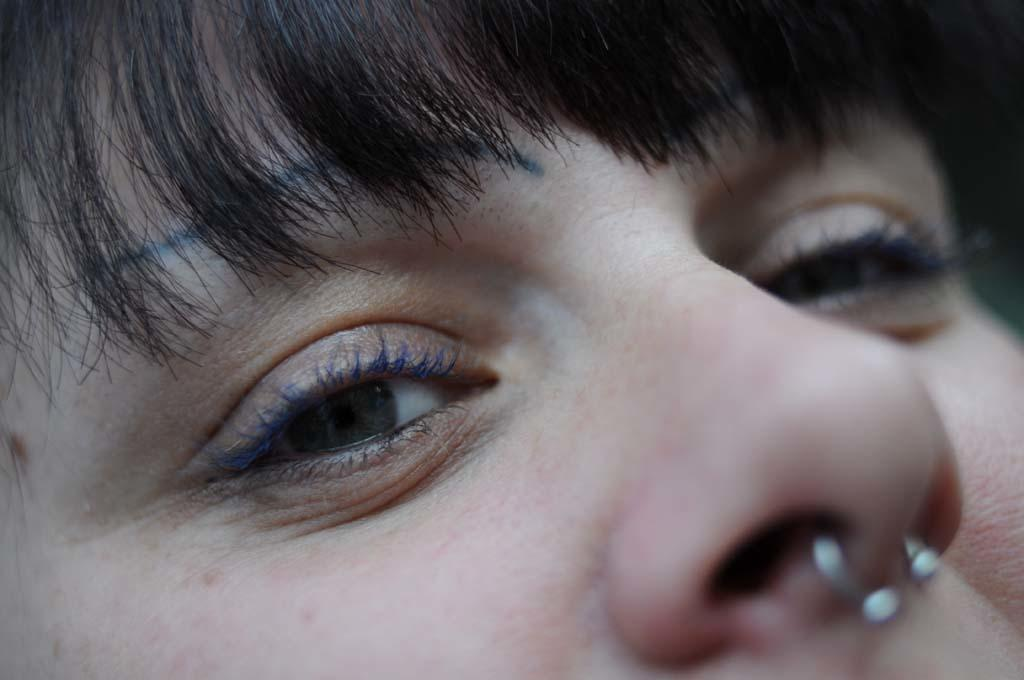What is present in the image? There is a person in the image. Can you describe any specific accessory the person is wearing? The person is wearing a nose pin. What can be observed about the person's hair on their forehead? The person's forehead is covered with hair. Can you see any trails left by a tank in the image? There is no mention of a tank or any trails in the image. What type of material is the person rubbing on their forehead in the image? There is no indication in the image that the person is rubbing anything on their forehead. 